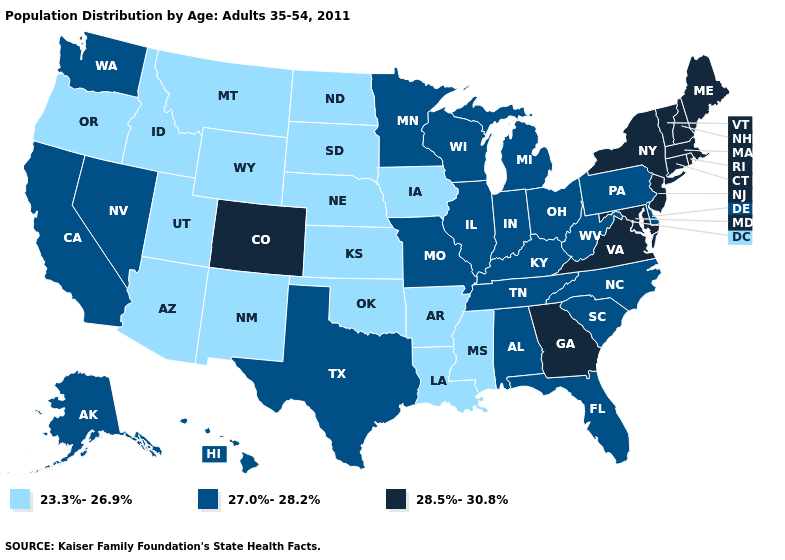Name the states that have a value in the range 28.5%-30.8%?
Answer briefly. Colorado, Connecticut, Georgia, Maine, Maryland, Massachusetts, New Hampshire, New Jersey, New York, Rhode Island, Vermont, Virginia. Is the legend a continuous bar?
Keep it brief. No. Name the states that have a value in the range 28.5%-30.8%?
Write a very short answer. Colorado, Connecticut, Georgia, Maine, Maryland, Massachusetts, New Hampshire, New Jersey, New York, Rhode Island, Vermont, Virginia. Which states have the lowest value in the USA?
Quick response, please. Arizona, Arkansas, Idaho, Iowa, Kansas, Louisiana, Mississippi, Montana, Nebraska, New Mexico, North Dakota, Oklahoma, Oregon, South Dakota, Utah, Wyoming. What is the lowest value in states that border Rhode Island?
Keep it brief. 28.5%-30.8%. What is the lowest value in the Northeast?
Write a very short answer. 27.0%-28.2%. What is the highest value in states that border Massachusetts?
Concise answer only. 28.5%-30.8%. What is the value of Idaho?
Short answer required. 23.3%-26.9%. Does Virginia have a higher value than New Hampshire?
Give a very brief answer. No. Which states hav the highest value in the South?
Give a very brief answer. Georgia, Maryland, Virginia. Is the legend a continuous bar?
Concise answer only. No. Among the states that border Colorado , which have the highest value?
Concise answer only. Arizona, Kansas, Nebraska, New Mexico, Oklahoma, Utah, Wyoming. What is the lowest value in states that border New Hampshire?
Be succinct. 28.5%-30.8%. What is the highest value in the USA?
Answer briefly. 28.5%-30.8%. What is the value of South Carolina?
Keep it brief. 27.0%-28.2%. 